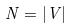Convert formula to latex. <formula><loc_0><loc_0><loc_500><loc_500>N = | V |</formula> 